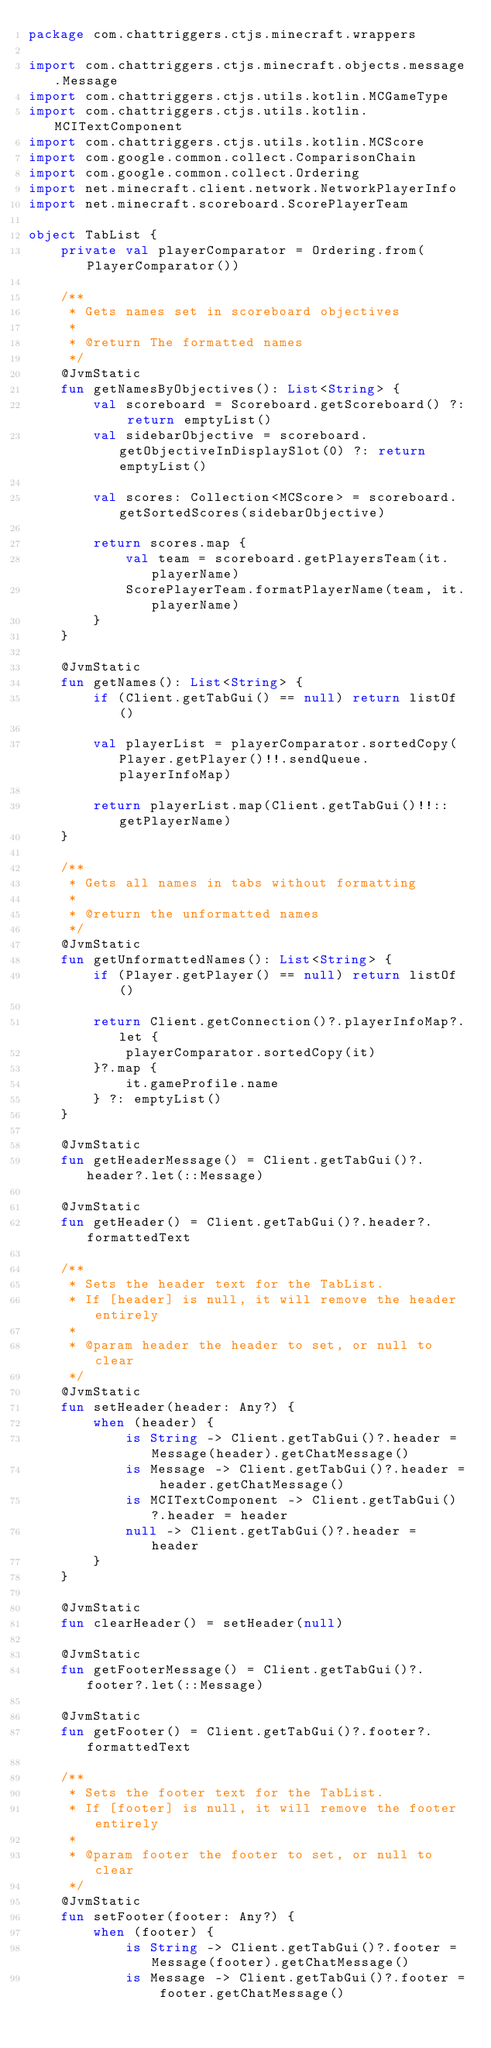<code> <loc_0><loc_0><loc_500><loc_500><_Kotlin_>package com.chattriggers.ctjs.minecraft.wrappers

import com.chattriggers.ctjs.minecraft.objects.message.Message
import com.chattriggers.ctjs.utils.kotlin.MCGameType
import com.chattriggers.ctjs.utils.kotlin.MCITextComponent
import com.chattriggers.ctjs.utils.kotlin.MCScore
import com.google.common.collect.ComparisonChain
import com.google.common.collect.Ordering
import net.minecraft.client.network.NetworkPlayerInfo
import net.minecraft.scoreboard.ScorePlayerTeam

object TabList {
    private val playerComparator = Ordering.from(PlayerComparator())

    /**
     * Gets names set in scoreboard objectives
     *
     * @return The formatted names
     */
    @JvmStatic
    fun getNamesByObjectives(): List<String> {
        val scoreboard = Scoreboard.getScoreboard() ?: return emptyList()
        val sidebarObjective = scoreboard.getObjectiveInDisplaySlot(0) ?: return emptyList()

        val scores: Collection<MCScore> = scoreboard.getSortedScores(sidebarObjective)

        return scores.map {
            val team = scoreboard.getPlayersTeam(it.playerName)
            ScorePlayerTeam.formatPlayerName(team, it.playerName)
        }
    }

    @JvmStatic
    fun getNames(): List<String> {
        if (Client.getTabGui() == null) return listOf()

        val playerList = playerComparator.sortedCopy(Player.getPlayer()!!.sendQueue.playerInfoMap)

        return playerList.map(Client.getTabGui()!!::getPlayerName)
    }

    /**
     * Gets all names in tabs without formatting
     *
     * @return the unformatted names
     */
    @JvmStatic
    fun getUnformattedNames(): List<String> {
        if (Player.getPlayer() == null) return listOf()

        return Client.getConnection()?.playerInfoMap?.let {
            playerComparator.sortedCopy(it)
        }?.map {
            it.gameProfile.name
        } ?: emptyList()
    }

    @JvmStatic
    fun getHeaderMessage() = Client.getTabGui()?.header?.let(::Message)

    @JvmStatic
    fun getHeader() = Client.getTabGui()?.header?.formattedText

    /**
     * Sets the header text for the TabList.
     * If [header] is null, it will remove the header entirely
     *
     * @param header the header to set, or null to clear
     */
    @JvmStatic
    fun setHeader(header: Any?) {
        when (header) {
            is String -> Client.getTabGui()?.header = Message(header).getChatMessage()
            is Message -> Client.getTabGui()?.header = header.getChatMessage()
            is MCITextComponent -> Client.getTabGui()?.header = header
            null -> Client.getTabGui()?.header = header
        }
    }

    @JvmStatic
    fun clearHeader() = setHeader(null)

    @JvmStatic
    fun getFooterMessage() = Client.getTabGui()?.footer?.let(::Message)

    @JvmStatic
    fun getFooter() = Client.getTabGui()?.footer?.formattedText

    /**
     * Sets the footer text for the TabList.
     * If [footer] is null, it will remove the footer entirely
     *
     * @param footer the footer to set, or null to clear
     */
    @JvmStatic
    fun setFooter(footer: Any?) {
        when (footer) {
            is String -> Client.getTabGui()?.footer = Message(footer).getChatMessage()
            is Message -> Client.getTabGui()?.footer = footer.getChatMessage()</code> 